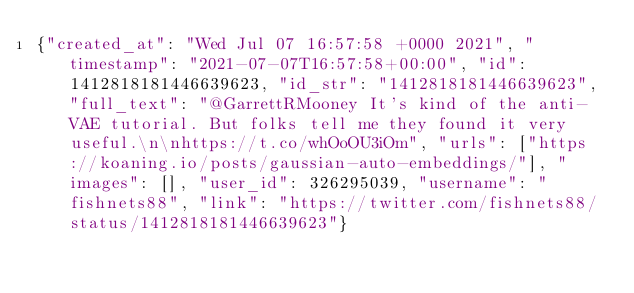Convert code to text. <code><loc_0><loc_0><loc_500><loc_500><_Julia_>{"created_at": "Wed Jul 07 16:57:58 +0000 2021", "timestamp": "2021-07-07T16:57:58+00:00", "id": 1412818181446639623, "id_str": "1412818181446639623", "full_text": "@GarrettRMooney It's kind of the anti-VAE tutorial. But folks tell me they found it very useful.\n\nhttps://t.co/whOoOU3iOm", "urls": ["https://koaning.io/posts/gaussian-auto-embeddings/"], "images": [], "user_id": 326295039, "username": "fishnets88", "link": "https://twitter.com/fishnets88/status/1412818181446639623"}
</code> 